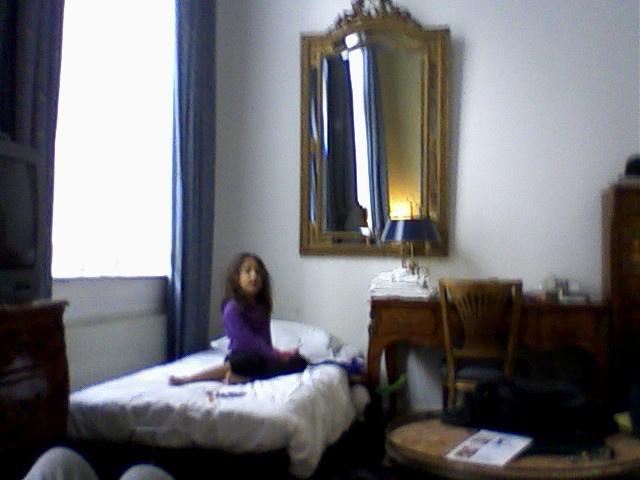What is the gender of the child?
Write a very short answer. Female. What is the room?
Be succinct. Bedroom. What is above the bed on the wall?
Give a very brief answer. Mirror. How many pillows are on the bed?
Answer briefly. 1. Are the drapes open?
Keep it brief. Yes. 